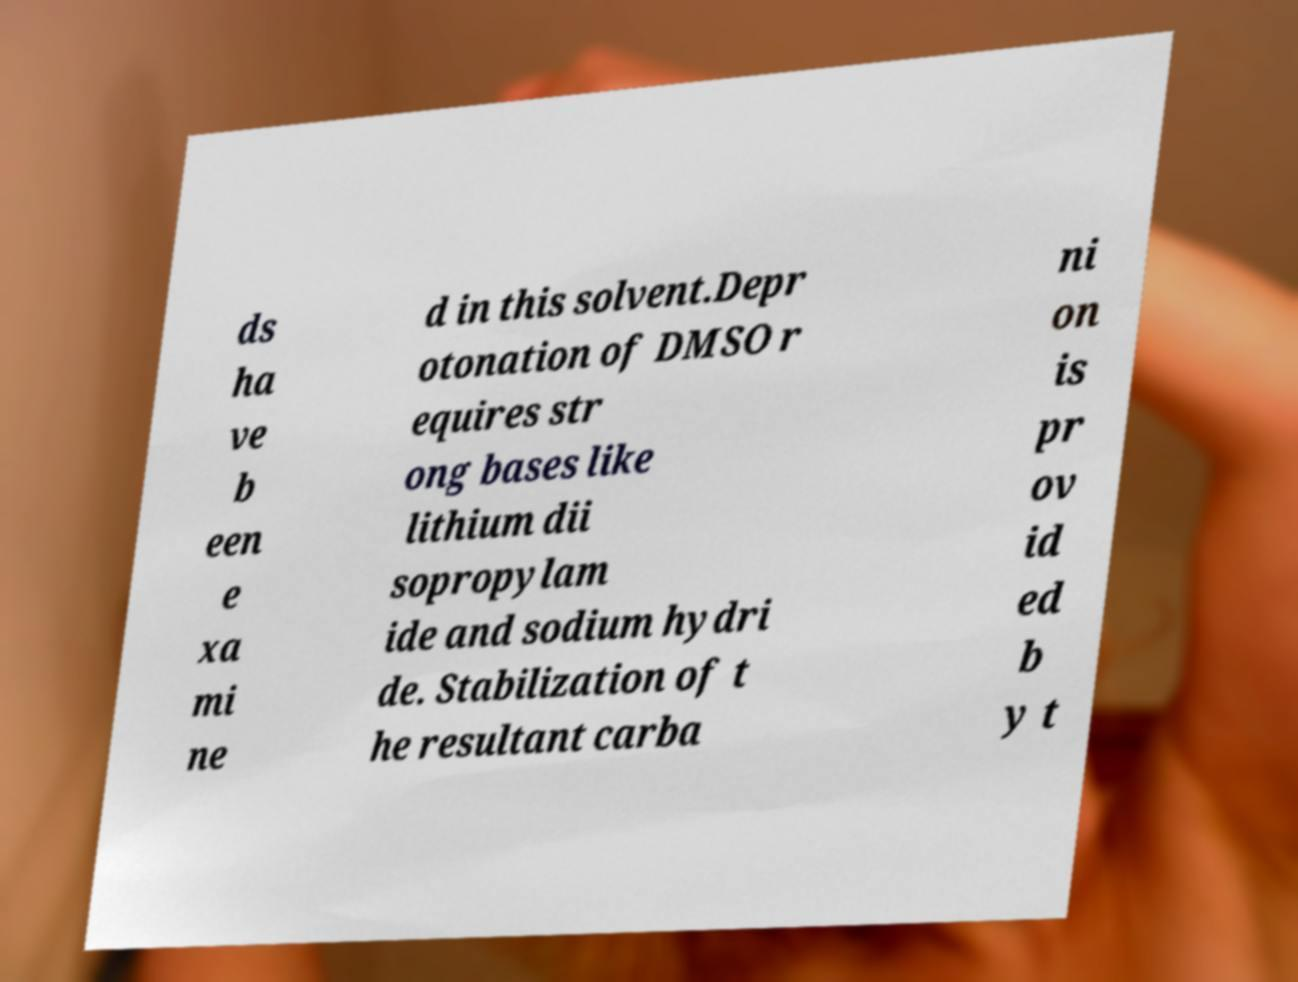There's text embedded in this image that I need extracted. Can you transcribe it verbatim? ds ha ve b een e xa mi ne d in this solvent.Depr otonation of DMSO r equires str ong bases like lithium dii sopropylam ide and sodium hydri de. Stabilization of t he resultant carba ni on is pr ov id ed b y t 